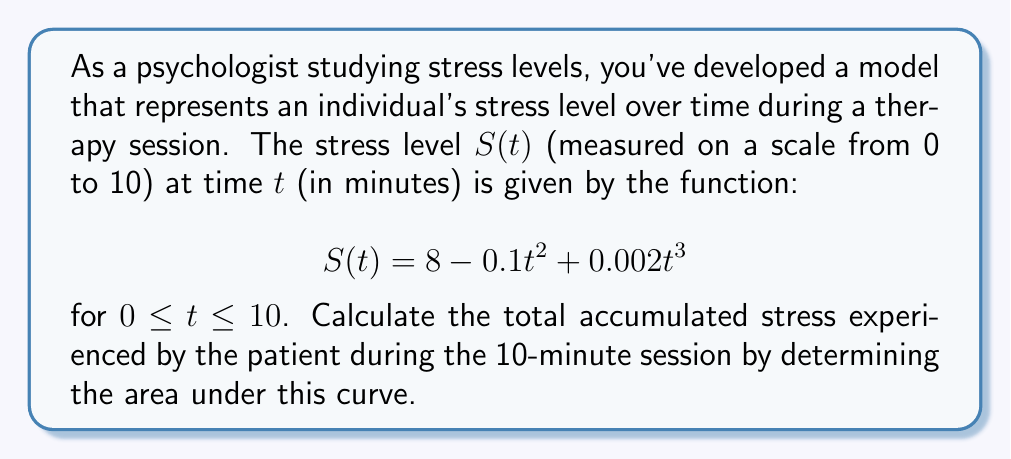What is the answer to this math problem? To find the total accumulated stress, we need to calculate the area under the curve $S(t)$ from $t=0$ to $t=10$. This can be done using definite integration.

1) Set up the definite integral:
   $$\int_0^{10} (8 - 0.1t^2 + 0.002t^3) dt$$

2) Integrate each term:
   $$\left[8t - \frac{0.1t^3}{3} + \frac{0.002t^4}{4}\right]_0^{10}$$

3) Evaluate at the upper and lower bounds:
   $$\left(80 - \frac{100}{3} + \frac{20}{4}\right) - \left(0 - 0 + 0\right)$$

4) Simplify:
   $$80 - \frac{100}{3} + 5 = 85 - \frac{100}{3}$$

5) Convert to a common denominator:
   $$\frac{255}{3} - \frac{100}{3} = \frac{155}{3}$$

The result represents the total accumulated stress in stress-minutes. This measure combines both the intensity of stress and the duration over which it was experienced.
Answer: $\frac{155}{3}$ stress-minutes 